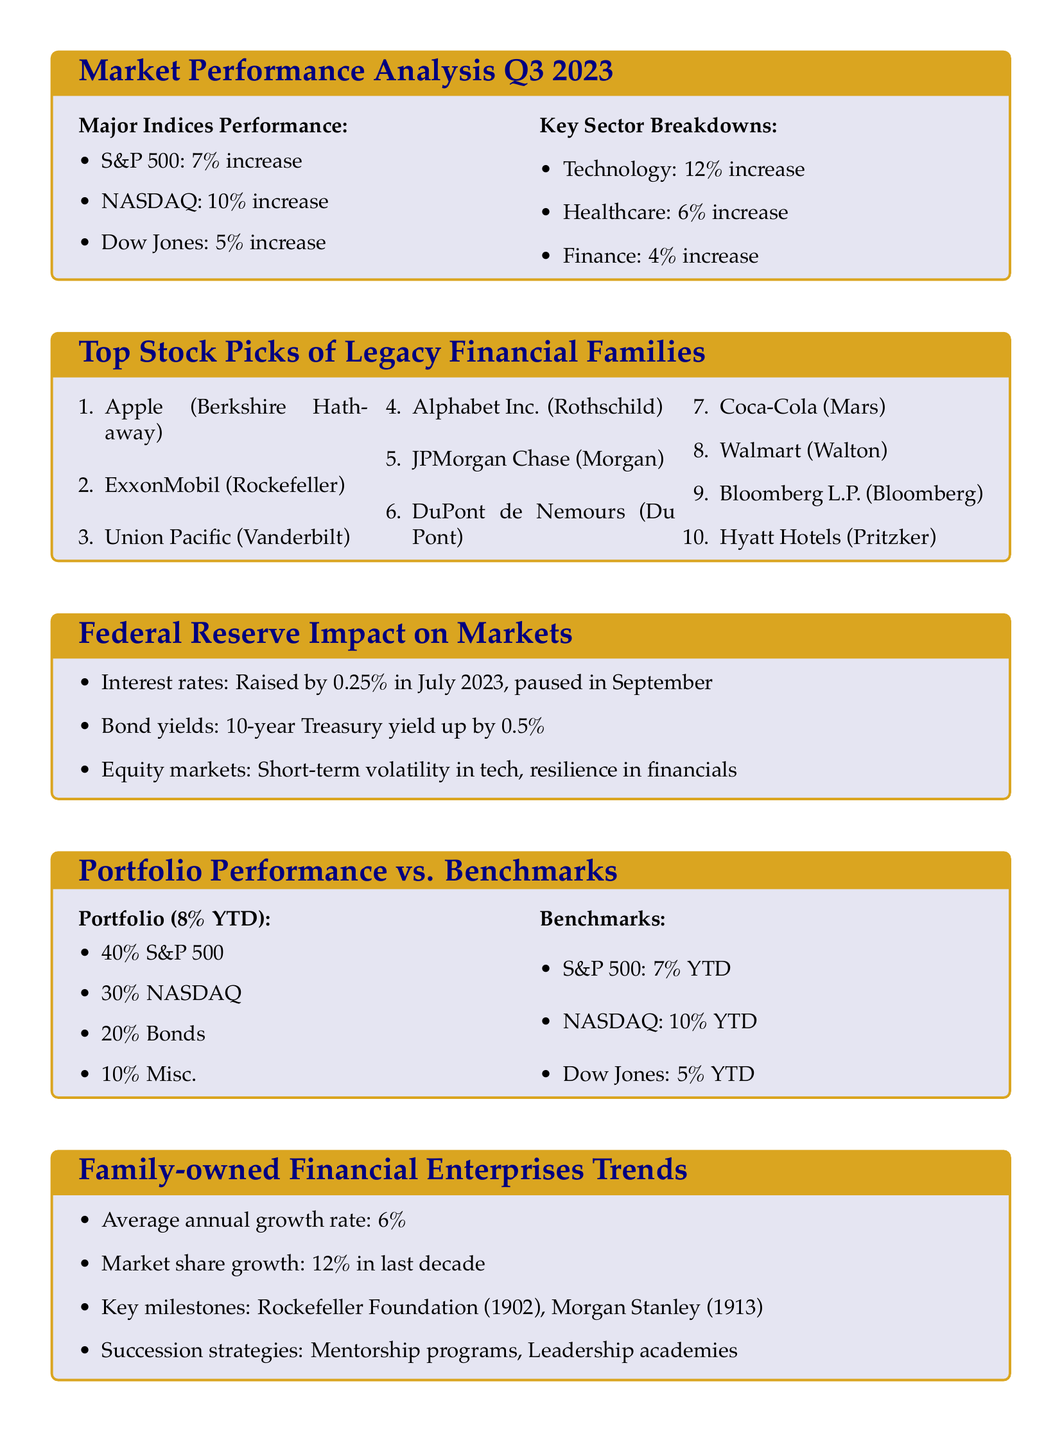What was the percentage increase of the NASDAQ in Q3 2023? The NASDAQ had a performance increase of 10% as stated in the Major Indices Performance section.
Answer: 10% Which sector showed the highest increase in Q3 2023? The Technology sector showed the highest increase at 12% as indicated in the Key Sector Breakdowns section.
Answer: Technology What is the average annual growth rate of family-owned financial enterprises? The document states that the average annual growth rate is 6% from the Family-owned Financial Enterprises Trends section.
Answer: 6% What stock is associated with the Morgan financial family? JPMorgan Chase is listed under the Top Stock Picks of Legacy Financial Families associated with the Morgan family.
Answer: JPMorgan Chase What was the change in 10-year Treasury yield? The document notes that the 10-year Treasury yield increased by 0.5% as part of the Federal Reserve Impact on Markets section.
Answer: 0.5% How does the portfolio performance compare to the S&P 500? The portfolio has a year-to-date performance of 8%, which is higher than the S&P 500's 7% as shown in the Portfolio Performance vs. Benchmarks section.
Answer: Higher 